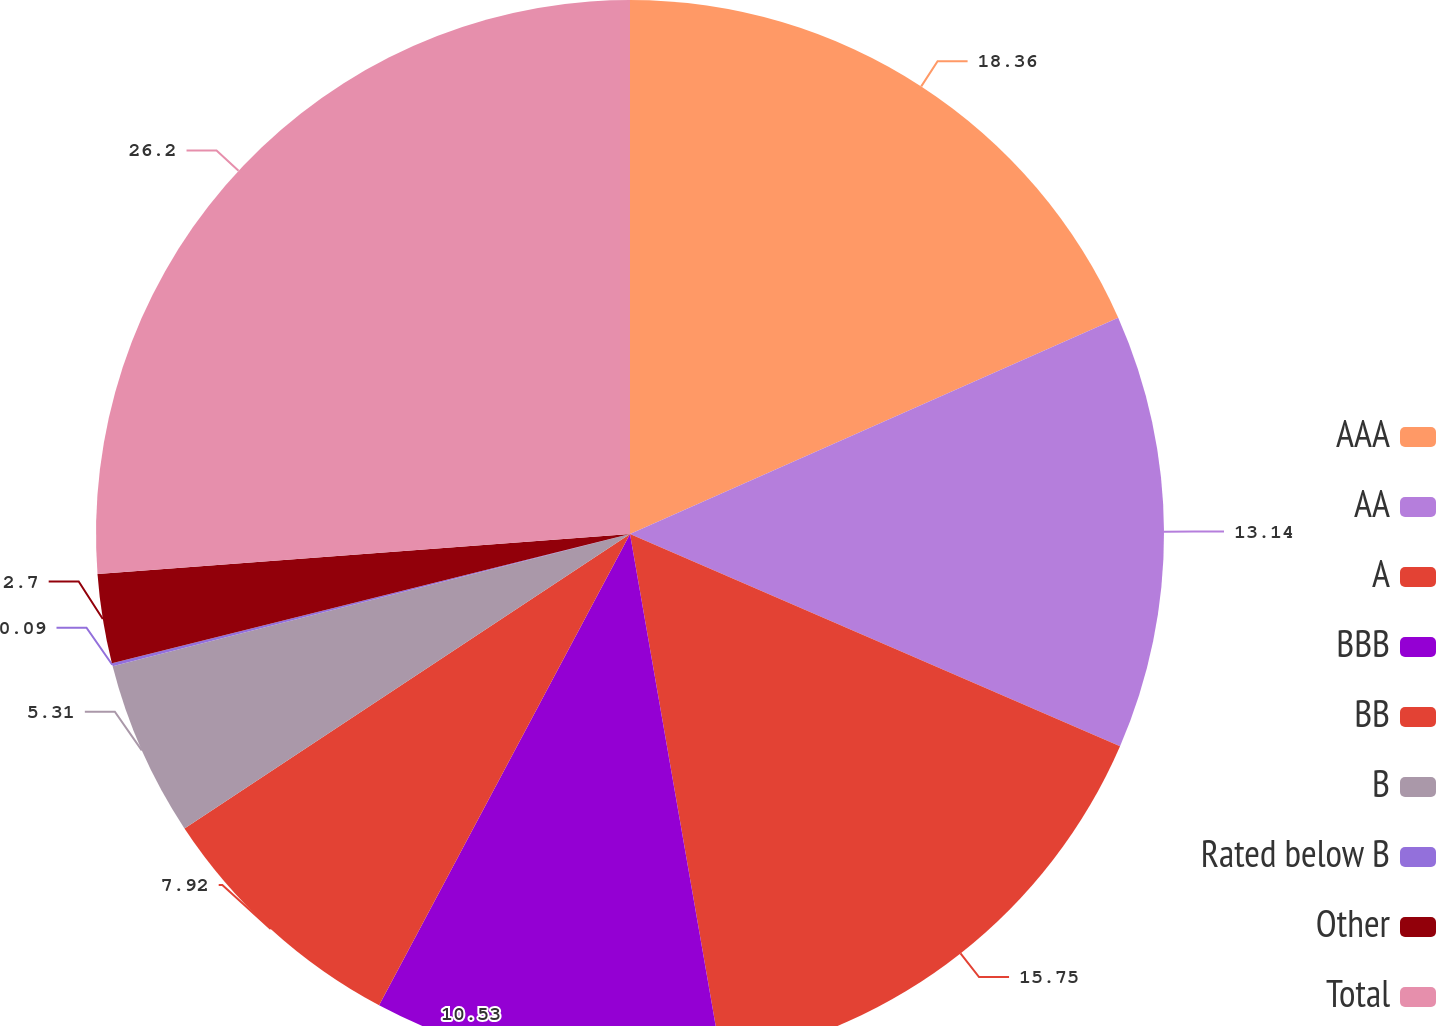Convert chart to OTSL. <chart><loc_0><loc_0><loc_500><loc_500><pie_chart><fcel>AAA<fcel>AA<fcel>A<fcel>BBB<fcel>BB<fcel>B<fcel>Rated below B<fcel>Other<fcel>Total<nl><fcel>18.36%<fcel>13.14%<fcel>15.75%<fcel>10.53%<fcel>7.92%<fcel>5.31%<fcel>0.09%<fcel>2.7%<fcel>26.19%<nl></chart> 